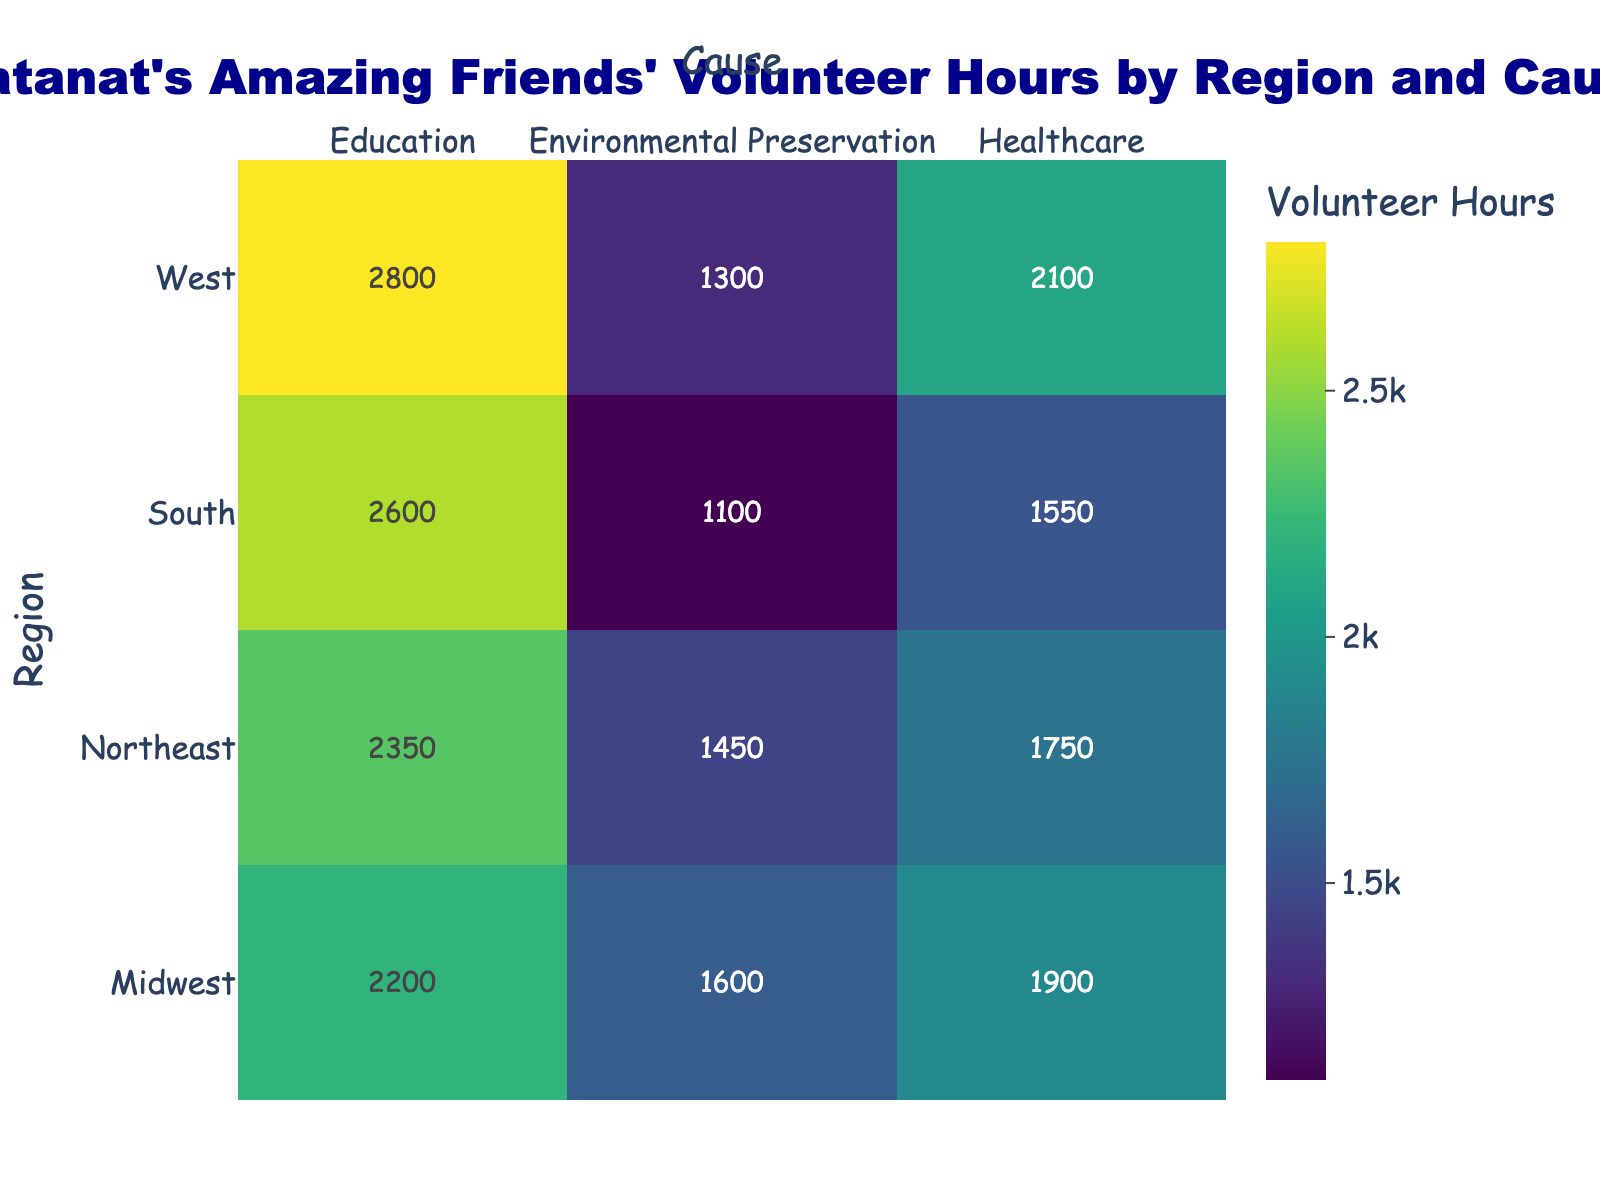what is the color scale used in the heatmap? The heatmap uses the 'Viridis' color scale, which ranges from dark purple for lower values to yellow for higher values. This can be inferred from the different shades present in the heatmap.
Answer: Viridis Which region contributed the most volunteer hours to education? In the heatmap, the West region has the brightest cell under the "Education" column, indicating the highest value. We can see from the color intensity that this region has the most hours.
Answer: West What's the total number of volunteer hours contributed by the Midwest region? To find the total, we sum all hours in the Midwest row: Education (2200) + Environmental Preservation (1600) + Healthcare (1900) = 5700.
Answer: 5700 How many volunteer hours were contributed to healthcare in the Northeast? In the heatmap, find the cell in the Northeast row under the Healthcare column. The value given is 1750 volunteer hours.
Answer: 1750 Which cause has the lowest volunteer hours in the South region? In the heatmap for the South region row, the cell with the lowest value appears under Environmental Preservation, which is 1100 hours.
Answer: Environmental Preservation What's the difference in volunteer hours contributed to Environmental Preservation between the Midwest and the South? From the heatmap, Midwest: 1600, South: 1100. Difference: 1600 - 1100 = 500.
Answer: 500 On average, how many volunteer hours did regions contribute to healthcare? Sum of hours in Healthcare column (1750 + 1900 + 1550 + 2100) = 7300. Average = 7300/4 = 1825.
Answer: 1825 What is the title of the heatmap? The title of the figure, as stated at the top center, is "Matanat's Amazing Friends' Volunteer Hours by Region and Cause".
Answer: Matanat's Amazing Friends' Volunteer Hours by Region and Cause Which region has the smallest variation in volunteer hours across the three causes? Calculate the range (max - min) for each region. Northeast: 2350 - 1450 = 900, Midwest: 2200 - 1600 = 600, South: 2600 - 1100 = 1500, West: 2800 - 1300 = 1500. The Midwest has the smallest range.
Answer: Midwest Which region has the highest total volunteer hours across all causes? Add all hours for each region and find the maximum. Northeast: 2350+1450+1750=5550, Midwest: 5700, South: 5250, West: 6200. The West region has the highest total.
Answer: West 